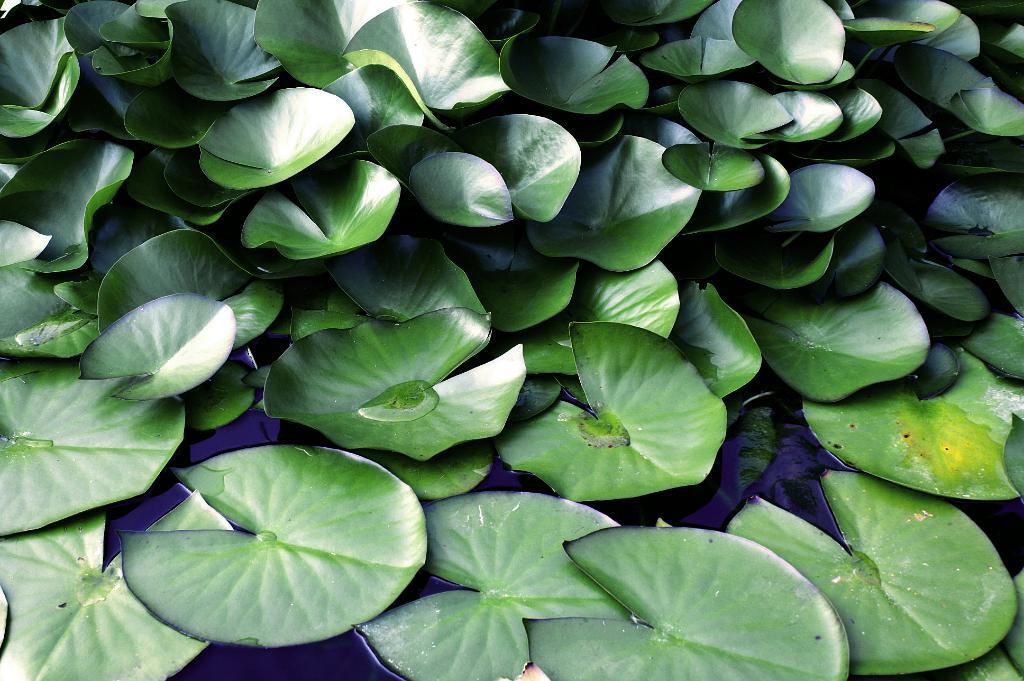Could you give a brief overview of what you see in this image? There are leaves on the water surface at the bottom side of the image and other leaves at the top side. 